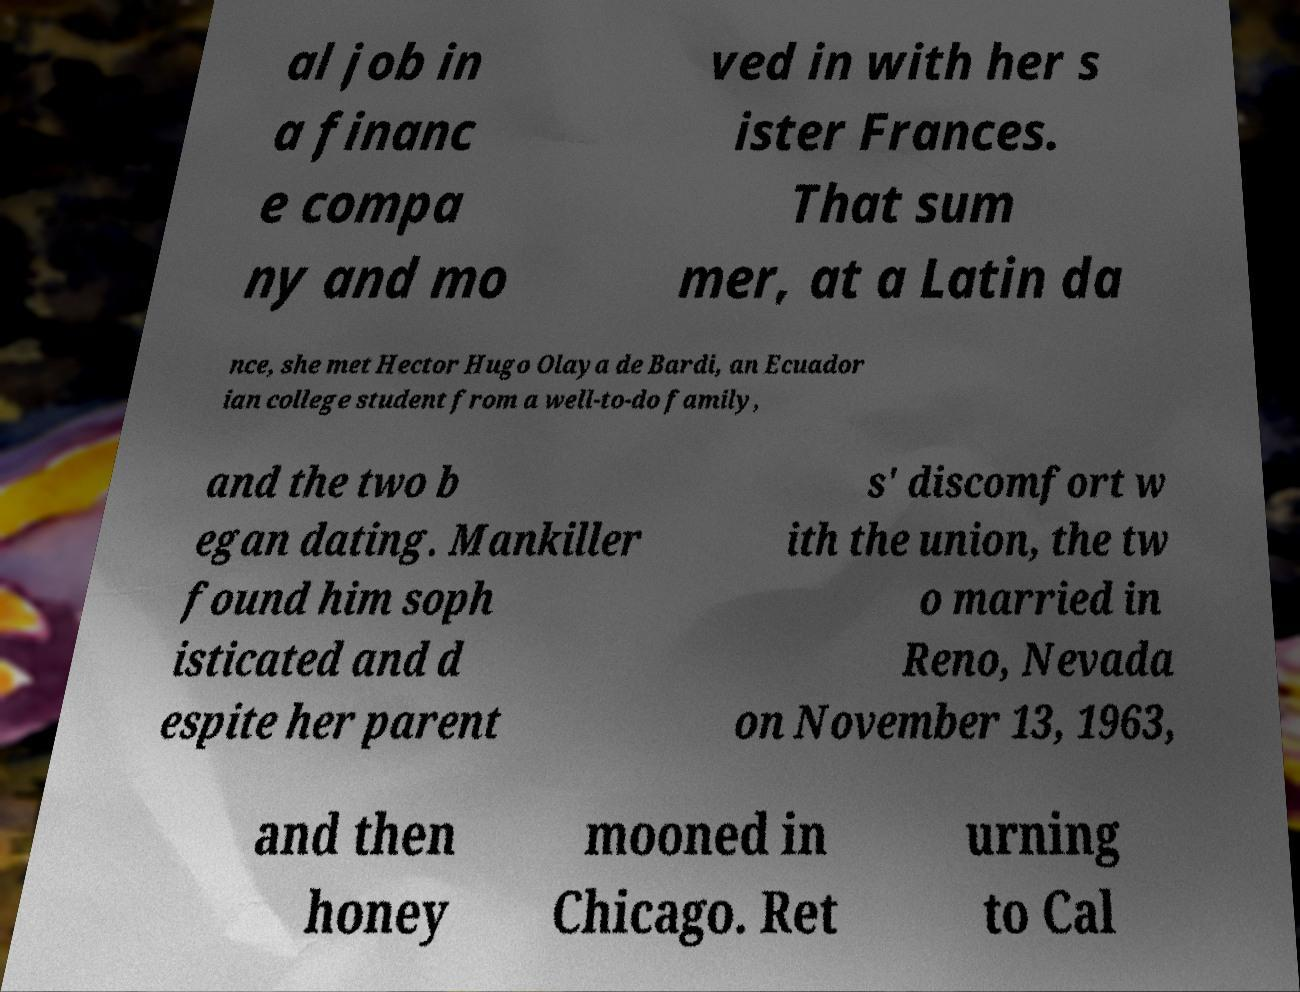Please identify and transcribe the text found in this image. al job in a financ e compa ny and mo ved in with her s ister Frances. That sum mer, at a Latin da nce, she met Hector Hugo Olaya de Bardi, an Ecuador ian college student from a well-to-do family, and the two b egan dating. Mankiller found him soph isticated and d espite her parent s' discomfort w ith the union, the tw o married in Reno, Nevada on November 13, 1963, and then honey mooned in Chicago. Ret urning to Cal 